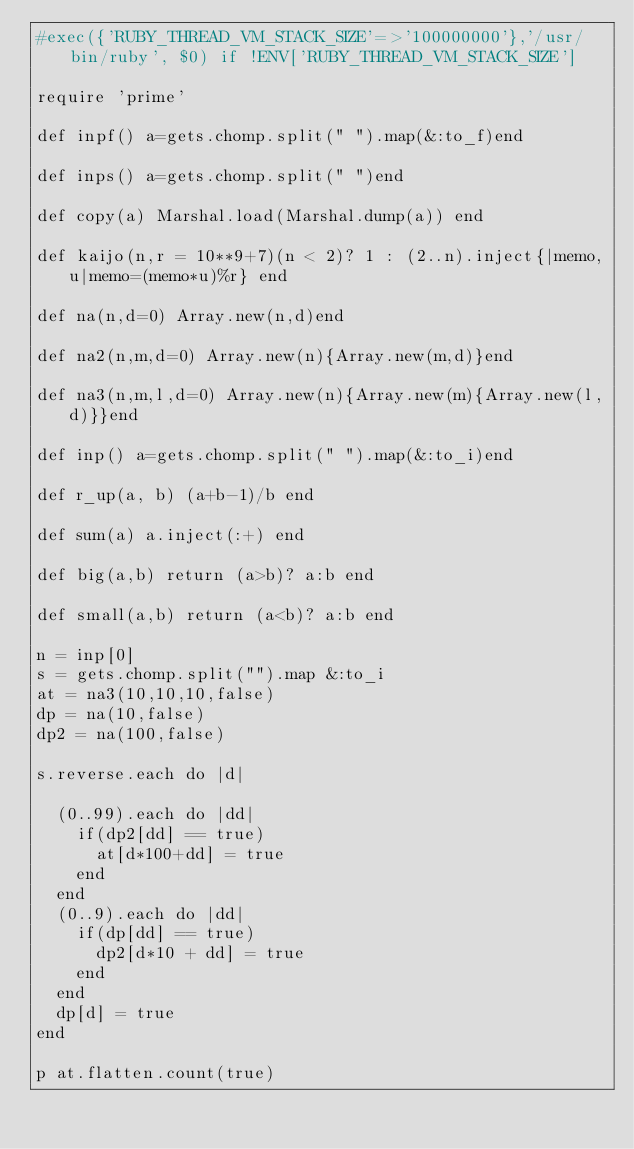<code> <loc_0><loc_0><loc_500><loc_500><_Ruby_>#exec({'RUBY_THREAD_VM_STACK_SIZE'=>'100000000'},'/usr/bin/ruby', $0) if !ENV['RUBY_THREAD_VM_STACK_SIZE']

require 'prime'

def inpf() a=gets.chomp.split(" ").map(&:to_f)end

def inps() a=gets.chomp.split(" ")end

def copy(a) Marshal.load(Marshal.dump(a)) end

def kaijo(n,r = 10**9+7)(n < 2)? 1 : (2..n).inject{|memo,u|memo=(memo*u)%r} end

def na(n,d=0) Array.new(n,d)end

def na2(n,m,d=0) Array.new(n){Array.new(m,d)}end

def na3(n,m,l,d=0) Array.new(n){Array.new(m){Array.new(l,d)}}end

def inp() a=gets.chomp.split(" ").map(&:to_i)end

def r_up(a, b) (a+b-1)/b end

def sum(a) a.inject(:+) end

def big(a,b) return (a>b)? a:b end

def small(a,b) return (a<b)? a:b end

n = inp[0]
s = gets.chomp.split("").map &:to_i
at = na3(10,10,10,false)
dp = na(10,false)
dp2 = na(100,false)

s.reverse.each do |d|

  (0..99).each do |dd|
    if(dp2[dd] == true)
      at[d*100+dd] = true
    end
  end
  (0..9).each do |dd|
    if(dp[dd] == true)
      dp2[d*10 + dd] = true
    end
  end
  dp[d] = true
end

p at.flatten.count(true)</code> 